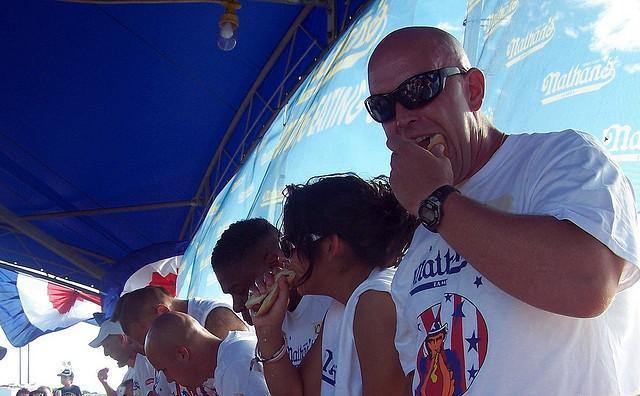How many people are in the photo?
Give a very brief answer. 6. How many birds are on the branch?
Give a very brief answer. 0. 